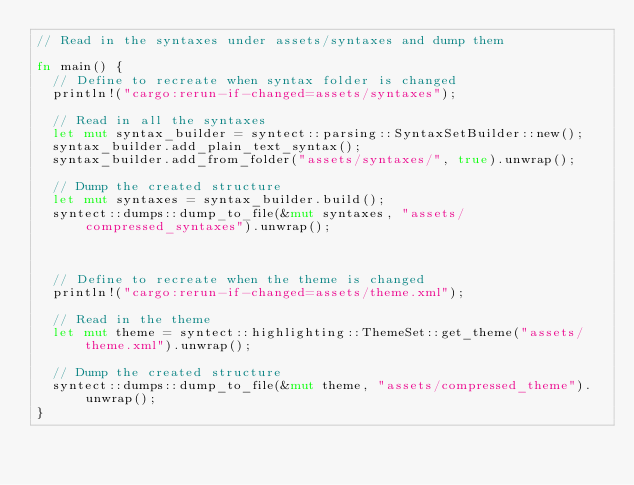Convert code to text. <code><loc_0><loc_0><loc_500><loc_500><_Rust_>// Read in the syntaxes under assets/syntaxes and dump them

fn main() {
  // Define to recreate when syntax folder is changed
  println!("cargo:rerun-if-changed=assets/syntaxes");

  // Read in all the syntaxes
  let mut syntax_builder = syntect::parsing::SyntaxSetBuilder::new();
  syntax_builder.add_plain_text_syntax();
  syntax_builder.add_from_folder("assets/syntaxes/", true).unwrap();

  // Dump the created structure
  let mut syntaxes = syntax_builder.build();
  syntect::dumps::dump_to_file(&mut syntaxes, "assets/compressed_syntaxes").unwrap();



  // Define to recreate when the theme is changed
  println!("cargo:rerun-if-changed=assets/theme.xml");

  // Read in the theme
  let mut theme = syntect::highlighting::ThemeSet::get_theme("assets/theme.xml").unwrap();

  // Dump the created structure
  syntect::dumps::dump_to_file(&mut theme, "assets/compressed_theme").unwrap();
}
</code> 